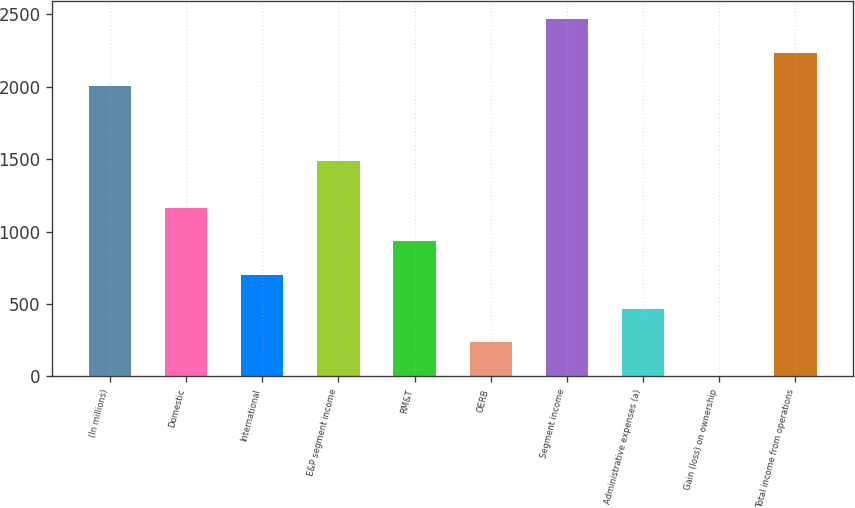Convert chart to OTSL. <chart><loc_0><loc_0><loc_500><loc_500><bar_chart><fcel>(In millions)<fcel>Domestic<fcel>International<fcel>E&P segment income<fcel>RM&T<fcel>OERB<fcel>Segment income<fcel>Administrative expenses (a)<fcel>Gain (loss) on ownership<fcel>Total income from operations<nl><fcel>2003<fcel>1165.5<fcel>699.7<fcel>1487<fcel>932.6<fcel>233.9<fcel>2468.8<fcel>466.8<fcel>1<fcel>2235.9<nl></chart> 